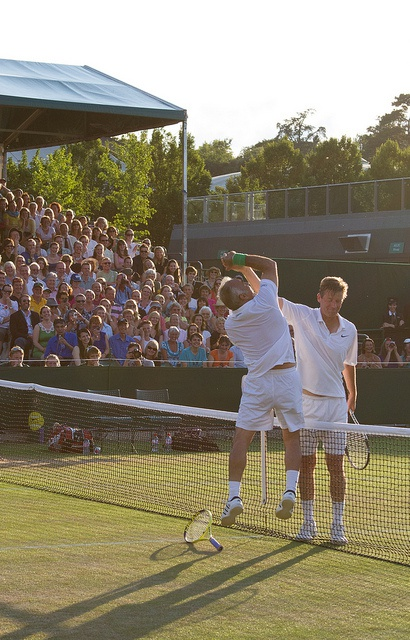Describe the objects in this image and their specific colors. I can see people in white, gray, maroon, and black tones, people in white, gray, maroon, and darkgray tones, people in white, darkgray, gray, and maroon tones, chair in white, gray, and black tones, and chair in white, black, and gray tones in this image. 